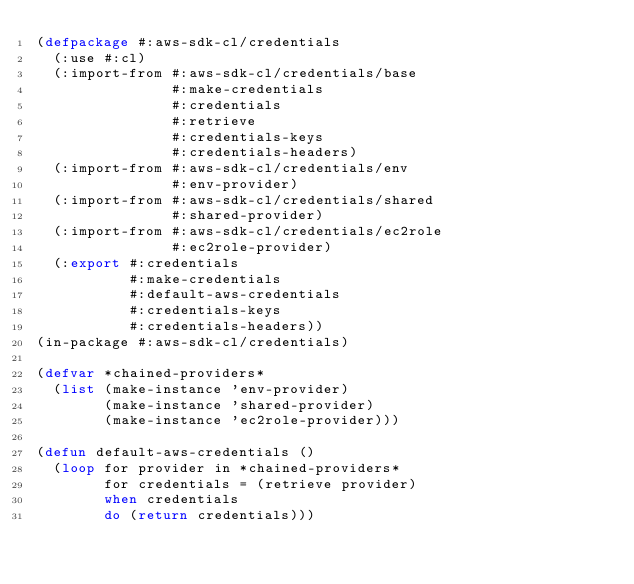<code> <loc_0><loc_0><loc_500><loc_500><_Lisp_>(defpackage #:aws-sdk-cl/credentials
  (:use #:cl)
  (:import-from #:aws-sdk-cl/credentials/base
                #:make-credentials
                #:credentials
                #:retrieve
                #:credentials-keys
                #:credentials-headers)
  (:import-from #:aws-sdk-cl/credentials/env
                #:env-provider)
  (:import-from #:aws-sdk-cl/credentials/shared
                #:shared-provider)
  (:import-from #:aws-sdk-cl/credentials/ec2role
                #:ec2role-provider)
  (:export #:credentials
           #:make-credentials
           #:default-aws-credentials
           #:credentials-keys
           #:credentials-headers))
(in-package #:aws-sdk-cl/credentials)

(defvar *chained-providers*
  (list (make-instance 'env-provider)
        (make-instance 'shared-provider)
        (make-instance 'ec2role-provider)))

(defun default-aws-credentials ()
  (loop for provider in *chained-providers*
        for credentials = (retrieve provider)
        when credentials
        do (return credentials)))
</code> 